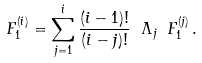<formula> <loc_0><loc_0><loc_500><loc_500>F ^ { ( i ) } _ { 1 } = \sum _ { j = 1 } ^ { i } \frac { ( i - 1 ) ! } { ( i - j ) ! } \ \Lambda _ { j } \ F ^ { ( j ) } _ { 1 } \, .</formula> 